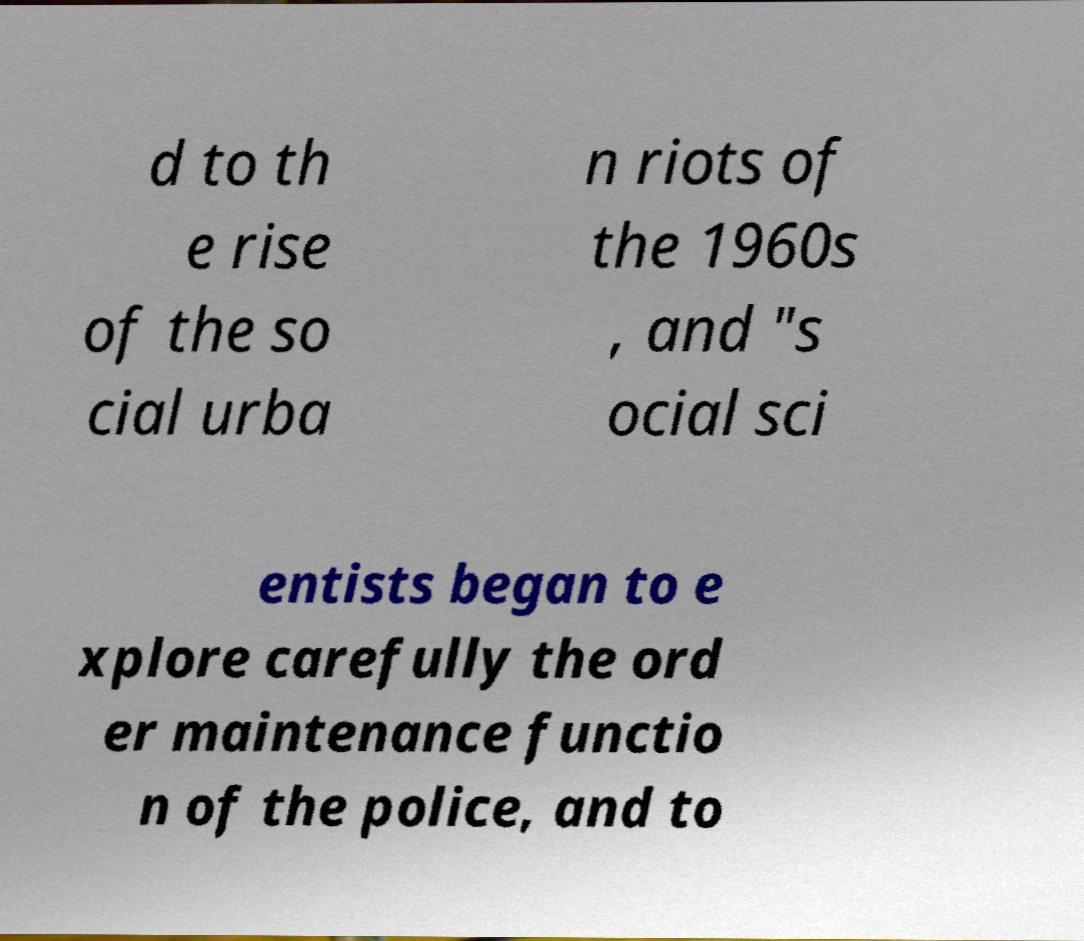There's text embedded in this image that I need extracted. Can you transcribe it verbatim? d to th e rise of the so cial urba n riots of the 1960s , and "s ocial sci entists began to e xplore carefully the ord er maintenance functio n of the police, and to 